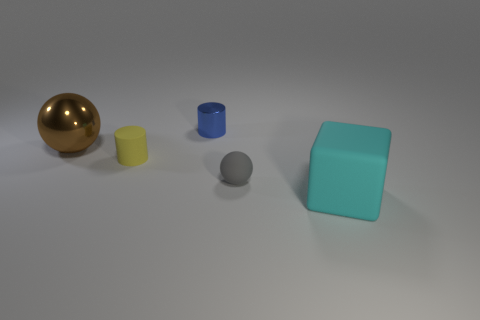Add 3 large green metallic cubes. How many objects exist? 8 Subtract all yellow cylinders. How many cylinders are left? 1 Subtract all blocks. How many objects are left? 4 Add 2 big brown metal balls. How many big brown metal balls are left? 3 Add 5 cyan things. How many cyan things exist? 6 Subtract 0 red cylinders. How many objects are left? 5 Subtract 1 balls. How many balls are left? 1 Subtract all gray cubes. Subtract all brown spheres. How many cubes are left? 1 Subtract all blue cylinders. How many gray spheres are left? 1 Subtract all cyan blocks. Subtract all matte balls. How many objects are left? 3 